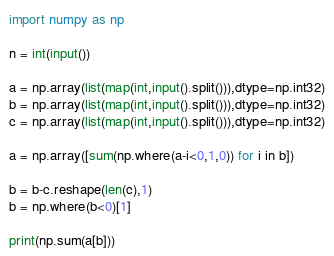Convert code to text. <code><loc_0><loc_0><loc_500><loc_500><_Python_>import numpy as np

n = int(input())

a = np.array(list(map(int,input().split())),dtype=np.int32)
b = np.array(list(map(int,input().split())),dtype=np.int32)
c = np.array(list(map(int,input().split())),dtype=np.int32)

a = np.array([sum(np.where(a-i<0,1,0)) for i in b])

b = b-c.reshape(len(c),1)
b = np.where(b<0)[1]

print(np.sum(a[b]))

</code> 